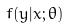<formula> <loc_0><loc_0><loc_500><loc_500>f ( y | x ; \theta )</formula> 